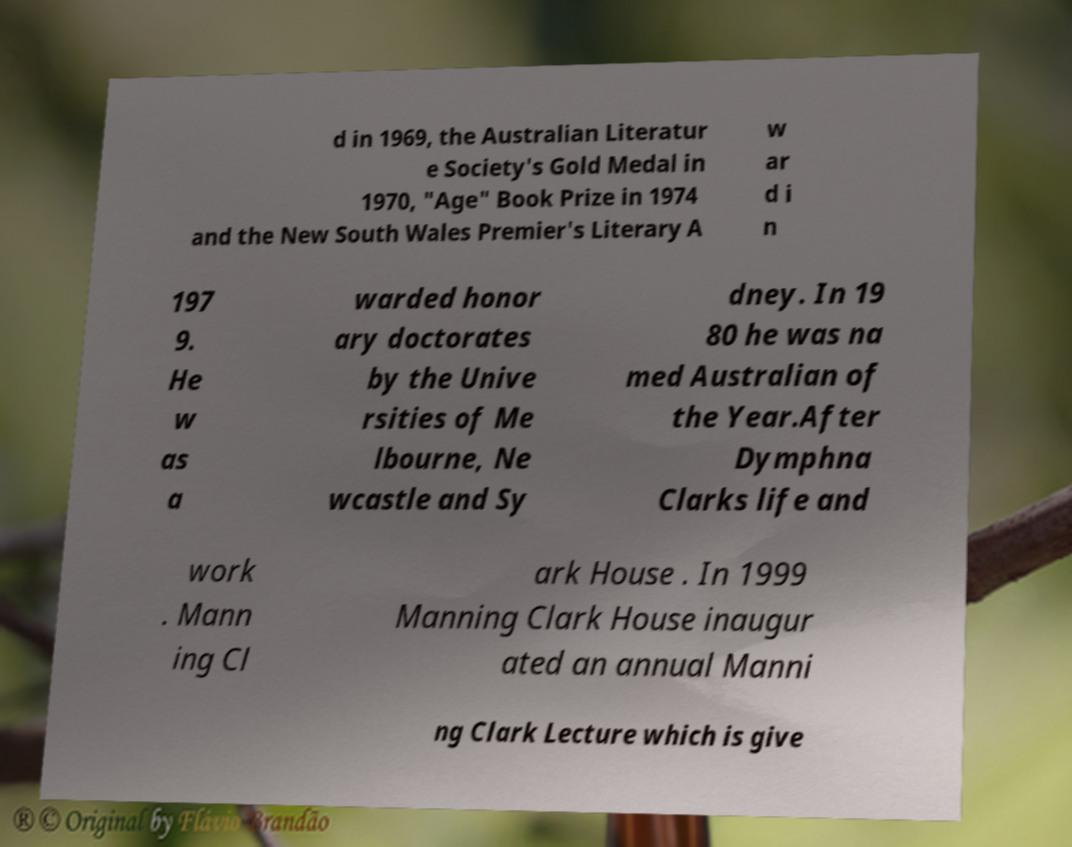Please identify and transcribe the text found in this image. d in 1969, the Australian Literatur e Society's Gold Medal in 1970, "Age" Book Prize in 1974 and the New South Wales Premier's Literary A w ar d i n 197 9. He w as a warded honor ary doctorates by the Unive rsities of Me lbourne, Ne wcastle and Sy dney. In 19 80 he was na med Australian of the Year.After Dymphna Clarks life and work . Mann ing Cl ark House . In 1999 Manning Clark House inaugur ated an annual Manni ng Clark Lecture which is give 